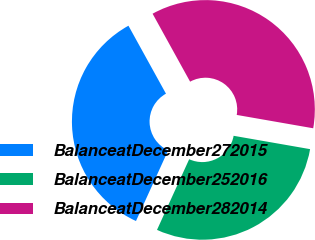Convert chart. <chart><loc_0><loc_0><loc_500><loc_500><pie_chart><fcel>BalanceatDecember272015<fcel>BalanceatDecember252016<fcel>BalanceatDecember282014<nl><fcel>35.17%<fcel>29.05%<fcel>35.78%<nl></chart> 